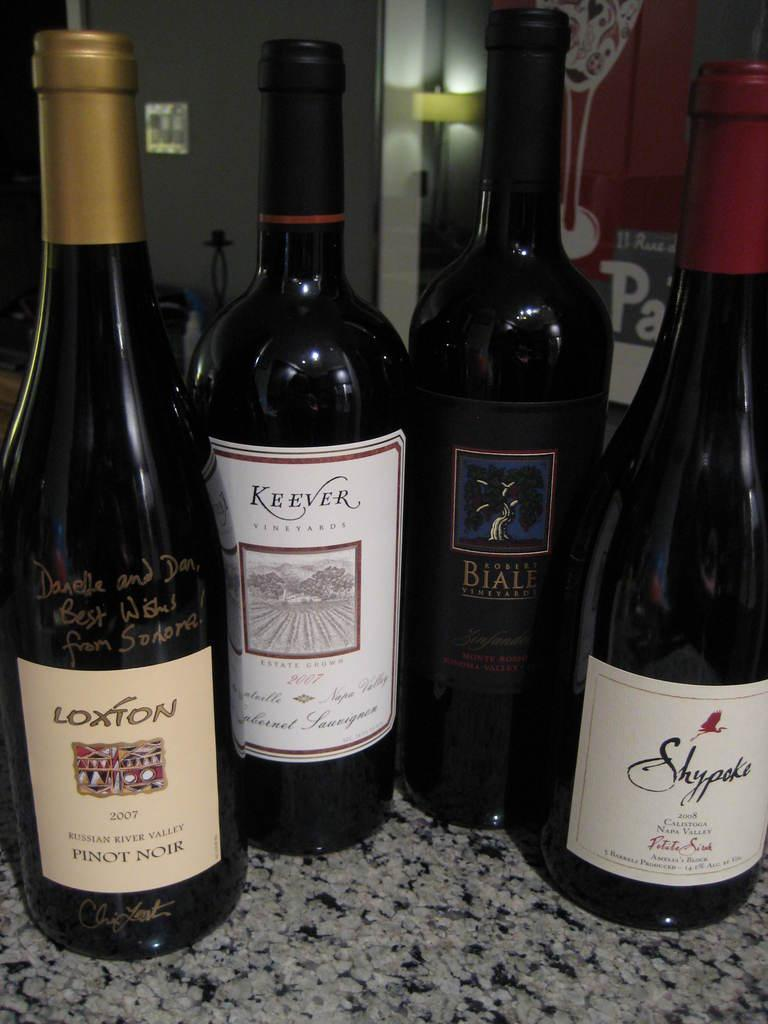<image>
Present a compact description of the photo's key features. Bottles of wine next to one anothe with one that has a label which says LOXTON. 